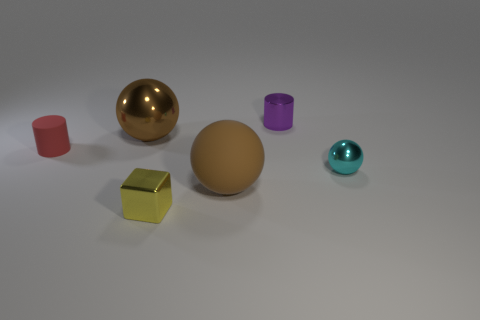There is a metal sphere that is behind the small cyan shiny thing; does it have the same size as the metallic thing that is in front of the big rubber thing?
Give a very brief answer. No. There is a small metal thing that is both left of the small cyan metallic ball and behind the matte sphere; what shape is it?
Make the answer very short. Cylinder. Is there another shiny block that has the same color as the tiny metal cube?
Ensure brevity in your answer.  No. Are there any small blocks?
Offer a very short reply. Yes. What is the color of the cylinder on the left side of the purple thing?
Make the answer very short. Red. Do the rubber sphere and the brown object that is behind the cyan sphere have the same size?
Make the answer very short. Yes. There is a object that is behind the small red thing and to the right of the big brown shiny ball; how big is it?
Ensure brevity in your answer.  Small. Are there any purple things made of the same material as the yellow thing?
Your answer should be very brief. Yes. The cyan object is what shape?
Provide a short and direct response. Sphere. Does the yellow block have the same size as the matte sphere?
Keep it short and to the point. No. 